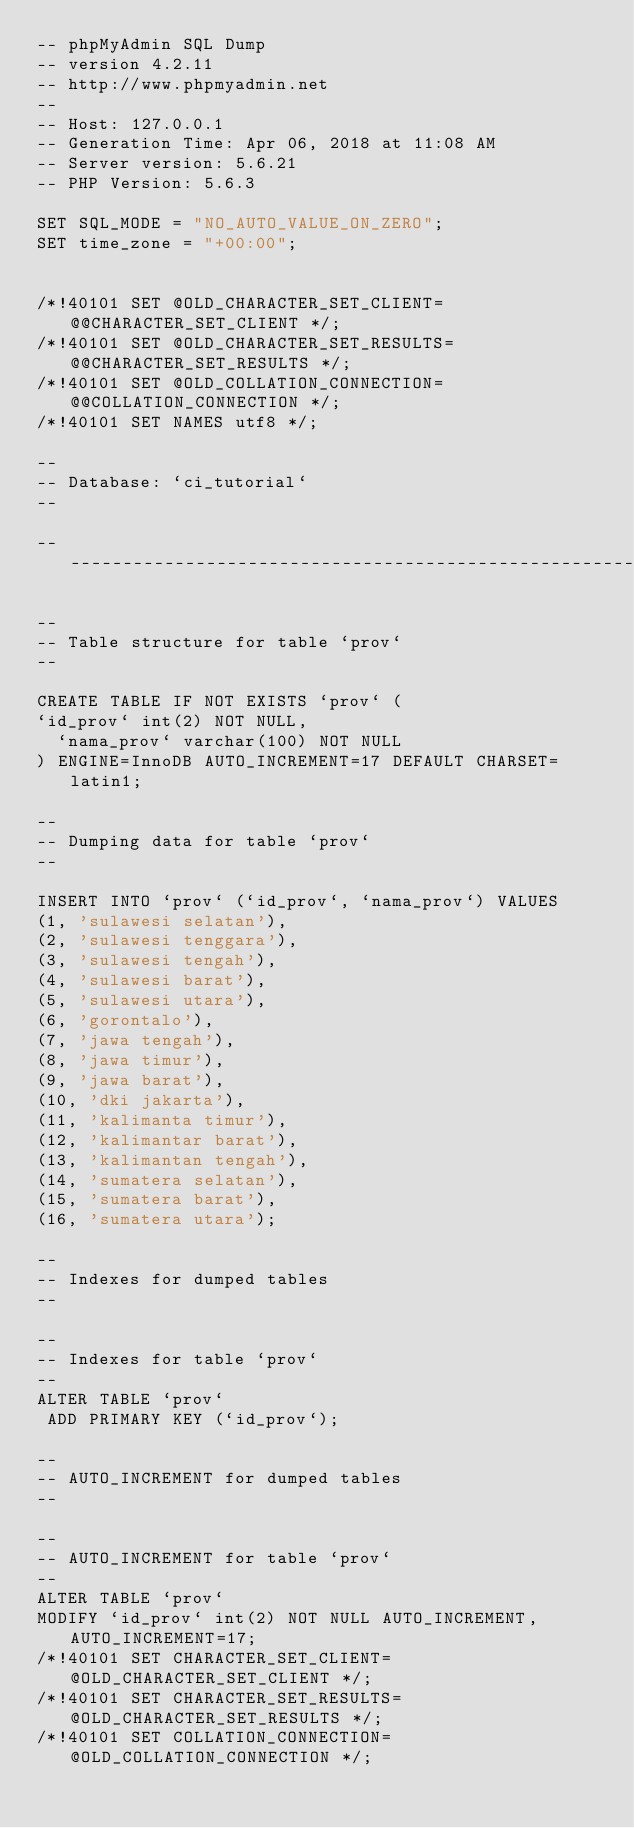Convert code to text. <code><loc_0><loc_0><loc_500><loc_500><_SQL_>-- phpMyAdmin SQL Dump
-- version 4.2.11
-- http://www.phpmyadmin.net
--
-- Host: 127.0.0.1
-- Generation Time: Apr 06, 2018 at 11:08 AM
-- Server version: 5.6.21
-- PHP Version: 5.6.3

SET SQL_MODE = "NO_AUTO_VALUE_ON_ZERO";
SET time_zone = "+00:00";


/*!40101 SET @OLD_CHARACTER_SET_CLIENT=@@CHARACTER_SET_CLIENT */;
/*!40101 SET @OLD_CHARACTER_SET_RESULTS=@@CHARACTER_SET_RESULTS */;
/*!40101 SET @OLD_COLLATION_CONNECTION=@@COLLATION_CONNECTION */;
/*!40101 SET NAMES utf8 */;

--
-- Database: `ci_tutorial`
--

-- --------------------------------------------------------

--
-- Table structure for table `prov`
--

CREATE TABLE IF NOT EXISTS `prov` (
`id_prov` int(2) NOT NULL,
  `nama_prov` varchar(100) NOT NULL
) ENGINE=InnoDB AUTO_INCREMENT=17 DEFAULT CHARSET=latin1;

--
-- Dumping data for table `prov`
--

INSERT INTO `prov` (`id_prov`, `nama_prov`) VALUES
(1, 'sulawesi selatan'),
(2, 'sulawesi tenggara'),
(3, 'sulawesi tengah'),
(4, 'sulawesi barat'),
(5, 'sulawesi utara'),
(6, 'gorontalo'),
(7, 'jawa tengah'),
(8, 'jawa timur'),
(9, 'jawa barat'),
(10, 'dki jakarta'),
(11, 'kalimanta timur'),
(12, 'kalimantar barat'),
(13, 'kalimantan tengah'),
(14, 'sumatera selatan'),
(15, 'sumatera barat'),
(16, 'sumatera utara');

--
-- Indexes for dumped tables
--

--
-- Indexes for table `prov`
--
ALTER TABLE `prov`
 ADD PRIMARY KEY (`id_prov`);

--
-- AUTO_INCREMENT for dumped tables
--

--
-- AUTO_INCREMENT for table `prov`
--
ALTER TABLE `prov`
MODIFY `id_prov` int(2) NOT NULL AUTO_INCREMENT,AUTO_INCREMENT=17;
/*!40101 SET CHARACTER_SET_CLIENT=@OLD_CHARACTER_SET_CLIENT */;
/*!40101 SET CHARACTER_SET_RESULTS=@OLD_CHARACTER_SET_RESULTS */;
/*!40101 SET COLLATION_CONNECTION=@OLD_COLLATION_CONNECTION */;
</code> 